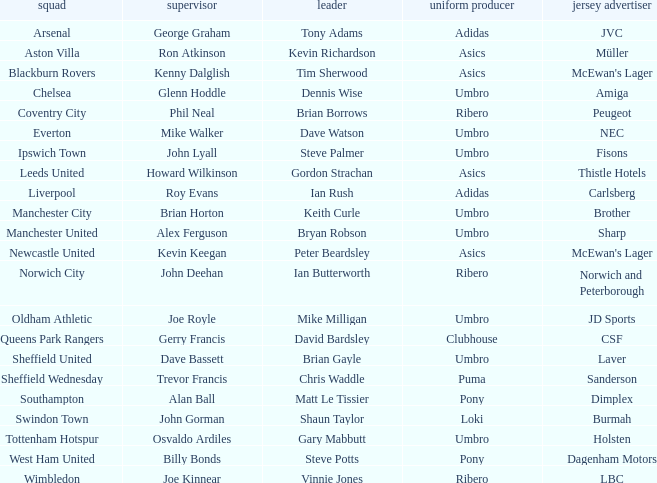Which captain has billy bonds as the manager? Steve Potts. Give me the full table as a dictionary. {'header': ['squad', 'supervisor', 'leader', 'uniform producer', 'jersey advertiser'], 'rows': [['Arsenal', 'George Graham', 'Tony Adams', 'Adidas', 'JVC'], ['Aston Villa', 'Ron Atkinson', 'Kevin Richardson', 'Asics', 'Müller'], ['Blackburn Rovers', 'Kenny Dalglish', 'Tim Sherwood', 'Asics', "McEwan's Lager"], ['Chelsea', 'Glenn Hoddle', 'Dennis Wise', 'Umbro', 'Amiga'], ['Coventry City', 'Phil Neal', 'Brian Borrows', 'Ribero', 'Peugeot'], ['Everton', 'Mike Walker', 'Dave Watson', 'Umbro', 'NEC'], ['Ipswich Town', 'John Lyall', 'Steve Palmer', 'Umbro', 'Fisons'], ['Leeds United', 'Howard Wilkinson', 'Gordon Strachan', 'Asics', 'Thistle Hotels'], ['Liverpool', 'Roy Evans', 'Ian Rush', 'Adidas', 'Carlsberg'], ['Manchester City', 'Brian Horton', 'Keith Curle', 'Umbro', 'Brother'], ['Manchester United', 'Alex Ferguson', 'Bryan Robson', 'Umbro', 'Sharp'], ['Newcastle United', 'Kevin Keegan', 'Peter Beardsley', 'Asics', "McEwan's Lager"], ['Norwich City', 'John Deehan', 'Ian Butterworth', 'Ribero', 'Norwich and Peterborough'], ['Oldham Athletic', 'Joe Royle', 'Mike Milligan', 'Umbro', 'JD Sports'], ['Queens Park Rangers', 'Gerry Francis', 'David Bardsley', 'Clubhouse', 'CSF'], ['Sheffield United', 'Dave Bassett', 'Brian Gayle', 'Umbro', 'Laver'], ['Sheffield Wednesday', 'Trevor Francis', 'Chris Waddle', 'Puma', 'Sanderson'], ['Southampton', 'Alan Ball', 'Matt Le Tissier', 'Pony', 'Dimplex'], ['Swindon Town', 'John Gorman', 'Shaun Taylor', 'Loki', 'Burmah'], ['Tottenham Hotspur', 'Osvaldo Ardiles', 'Gary Mabbutt', 'Umbro', 'Holsten'], ['West Ham United', 'Billy Bonds', 'Steve Potts', 'Pony', 'Dagenham Motors'], ['Wimbledon', 'Joe Kinnear', 'Vinnie Jones', 'Ribero', 'LBC']]} 